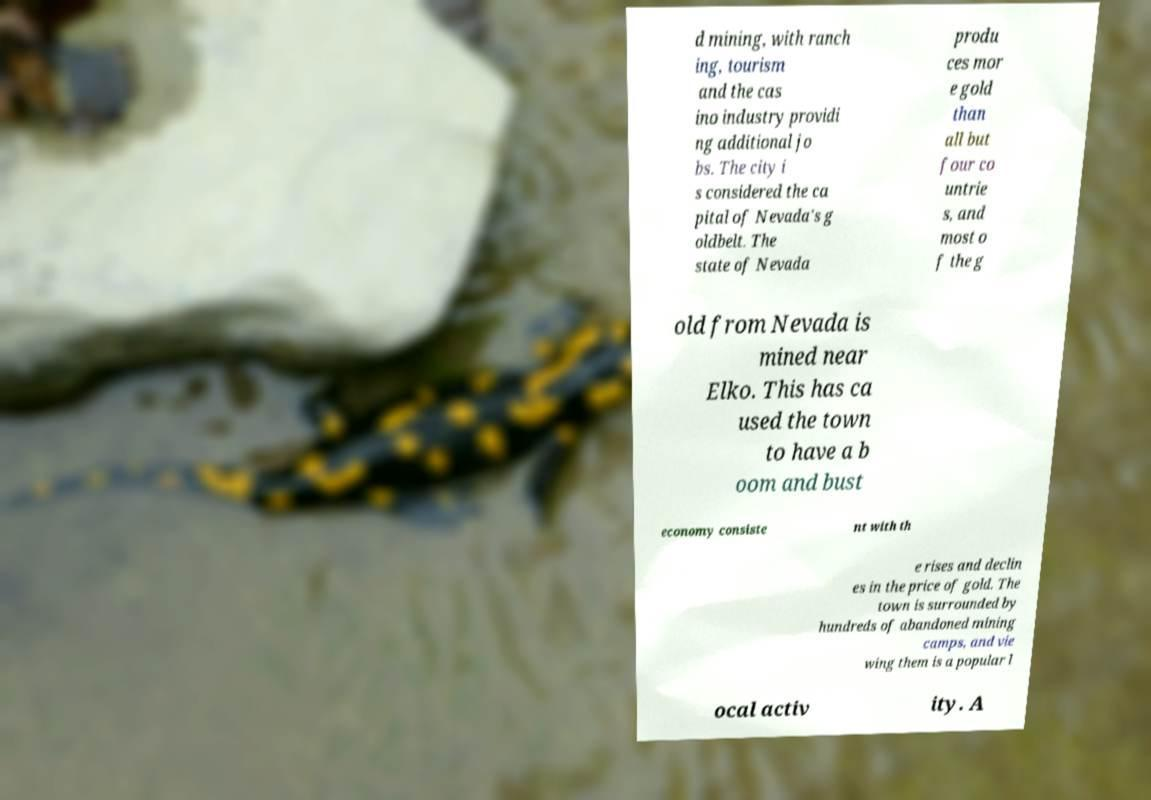Could you assist in decoding the text presented in this image and type it out clearly? d mining, with ranch ing, tourism and the cas ino industry providi ng additional jo bs. The city i s considered the ca pital of Nevada's g oldbelt. The state of Nevada produ ces mor e gold than all but four co untrie s, and most o f the g old from Nevada is mined near Elko. This has ca used the town to have a b oom and bust economy consiste nt with th e rises and declin es in the price of gold. The town is surrounded by hundreds of abandoned mining camps, and vie wing them is a popular l ocal activ ity. A 